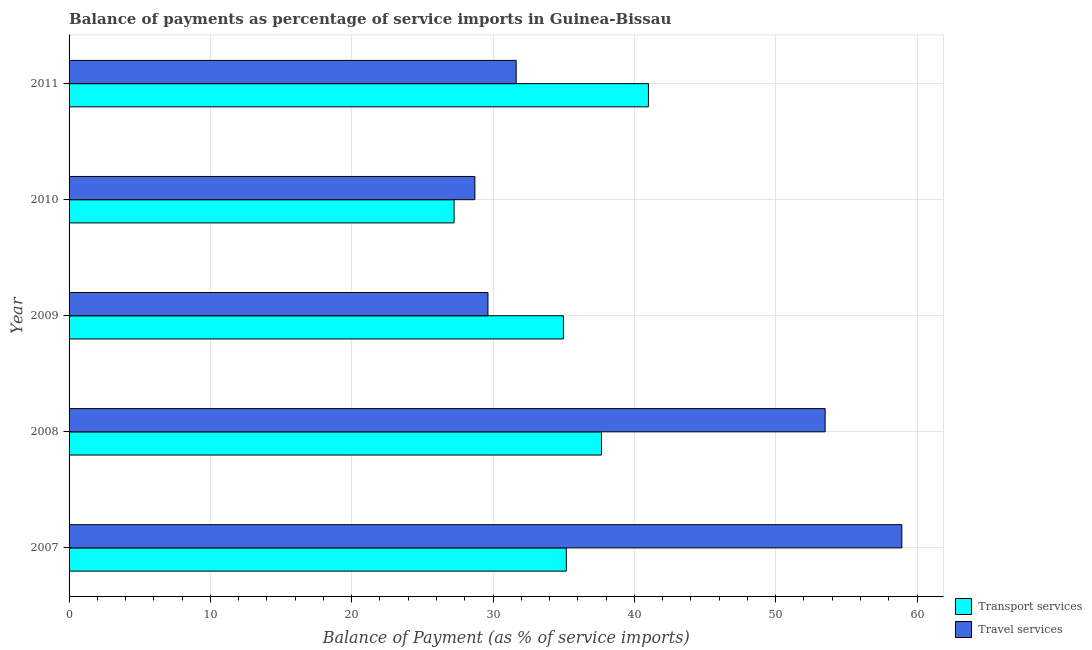How many different coloured bars are there?
Give a very brief answer. 2. Are the number of bars on each tick of the Y-axis equal?
Offer a terse response. Yes. How many bars are there on the 5th tick from the top?
Your answer should be compact. 2. How many bars are there on the 4th tick from the bottom?
Your response must be concise. 2. What is the balance of payments of travel services in 2009?
Your answer should be very brief. 29.64. Across all years, what is the maximum balance of payments of transport services?
Keep it short and to the point. 40.99. Across all years, what is the minimum balance of payments of travel services?
Provide a short and direct response. 28.71. In which year was the balance of payments of travel services minimum?
Provide a short and direct response. 2010. What is the total balance of payments of transport services in the graph?
Your answer should be very brief. 176.07. What is the difference between the balance of payments of transport services in 2008 and that in 2011?
Provide a short and direct response. -3.32. What is the difference between the balance of payments of transport services in 2008 and the balance of payments of travel services in 2007?
Ensure brevity in your answer.  -21.25. What is the average balance of payments of transport services per year?
Your answer should be compact. 35.22. In the year 2011, what is the difference between the balance of payments of travel services and balance of payments of transport services?
Offer a very short reply. -9.36. In how many years, is the balance of payments of transport services greater than 40 %?
Give a very brief answer. 1. What is the ratio of the balance of payments of transport services in 2007 to that in 2011?
Your answer should be compact. 0.86. Is the balance of payments of travel services in 2007 less than that in 2009?
Provide a succinct answer. No. Is the difference between the balance of payments of transport services in 2010 and 2011 greater than the difference between the balance of payments of travel services in 2010 and 2011?
Offer a terse response. No. What is the difference between the highest and the second highest balance of payments of transport services?
Give a very brief answer. 3.32. What is the difference between the highest and the lowest balance of payments of transport services?
Ensure brevity in your answer.  13.75. Is the sum of the balance of payments of transport services in 2007 and 2011 greater than the maximum balance of payments of travel services across all years?
Provide a succinct answer. Yes. What does the 1st bar from the top in 2010 represents?
Your answer should be very brief. Travel services. What does the 2nd bar from the bottom in 2011 represents?
Provide a succinct answer. Travel services. How many bars are there?
Ensure brevity in your answer.  10. Are all the bars in the graph horizontal?
Provide a succinct answer. Yes. How many years are there in the graph?
Provide a succinct answer. 5. What is the difference between two consecutive major ticks on the X-axis?
Offer a very short reply. 10. Does the graph contain any zero values?
Your answer should be compact. No. Does the graph contain grids?
Provide a succinct answer. Yes. Where does the legend appear in the graph?
Your answer should be very brief. Bottom right. How many legend labels are there?
Offer a terse response. 2. What is the title of the graph?
Provide a succinct answer. Balance of payments as percentage of service imports in Guinea-Bissau. What is the label or title of the X-axis?
Provide a succinct answer. Balance of Payment (as % of service imports). What is the Balance of Payment (as % of service imports) of Transport services in 2007?
Offer a terse response. 35.18. What is the Balance of Payment (as % of service imports) in Travel services in 2007?
Your response must be concise. 58.92. What is the Balance of Payment (as % of service imports) of Transport services in 2008?
Your answer should be compact. 37.67. What is the Balance of Payment (as % of service imports) of Travel services in 2008?
Make the answer very short. 53.5. What is the Balance of Payment (as % of service imports) in Transport services in 2009?
Your answer should be compact. 34.98. What is the Balance of Payment (as % of service imports) in Travel services in 2009?
Make the answer very short. 29.64. What is the Balance of Payment (as % of service imports) of Transport services in 2010?
Make the answer very short. 27.24. What is the Balance of Payment (as % of service imports) in Travel services in 2010?
Your response must be concise. 28.71. What is the Balance of Payment (as % of service imports) of Transport services in 2011?
Ensure brevity in your answer.  40.99. What is the Balance of Payment (as % of service imports) in Travel services in 2011?
Ensure brevity in your answer.  31.64. Across all years, what is the maximum Balance of Payment (as % of service imports) in Transport services?
Offer a terse response. 40.99. Across all years, what is the maximum Balance of Payment (as % of service imports) in Travel services?
Give a very brief answer. 58.92. Across all years, what is the minimum Balance of Payment (as % of service imports) in Transport services?
Provide a short and direct response. 27.24. Across all years, what is the minimum Balance of Payment (as % of service imports) of Travel services?
Your answer should be compact. 28.71. What is the total Balance of Payment (as % of service imports) of Transport services in the graph?
Ensure brevity in your answer.  176.07. What is the total Balance of Payment (as % of service imports) of Travel services in the graph?
Offer a very short reply. 202.41. What is the difference between the Balance of Payment (as % of service imports) of Transport services in 2007 and that in 2008?
Make the answer very short. -2.49. What is the difference between the Balance of Payment (as % of service imports) of Travel services in 2007 and that in 2008?
Offer a terse response. 5.43. What is the difference between the Balance of Payment (as % of service imports) of Transport services in 2007 and that in 2009?
Provide a succinct answer. 0.21. What is the difference between the Balance of Payment (as % of service imports) in Travel services in 2007 and that in 2009?
Your answer should be very brief. 29.29. What is the difference between the Balance of Payment (as % of service imports) in Transport services in 2007 and that in 2010?
Give a very brief answer. 7.94. What is the difference between the Balance of Payment (as % of service imports) of Travel services in 2007 and that in 2010?
Keep it short and to the point. 30.21. What is the difference between the Balance of Payment (as % of service imports) of Transport services in 2007 and that in 2011?
Make the answer very short. -5.81. What is the difference between the Balance of Payment (as % of service imports) of Travel services in 2007 and that in 2011?
Your answer should be compact. 27.29. What is the difference between the Balance of Payment (as % of service imports) of Transport services in 2008 and that in 2009?
Offer a very short reply. 2.69. What is the difference between the Balance of Payment (as % of service imports) in Travel services in 2008 and that in 2009?
Offer a terse response. 23.86. What is the difference between the Balance of Payment (as % of service imports) in Transport services in 2008 and that in 2010?
Give a very brief answer. 10.43. What is the difference between the Balance of Payment (as % of service imports) of Travel services in 2008 and that in 2010?
Your answer should be very brief. 24.78. What is the difference between the Balance of Payment (as % of service imports) in Transport services in 2008 and that in 2011?
Your response must be concise. -3.32. What is the difference between the Balance of Payment (as % of service imports) in Travel services in 2008 and that in 2011?
Provide a short and direct response. 21.86. What is the difference between the Balance of Payment (as % of service imports) of Transport services in 2009 and that in 2010?
Your answer should be very brief. 7.74. What is the difference between the Balance of Payment (as % of service imports) in Travel services in 2009 and that in 2010?
Provide a short and direct response. 0.92. What is the difference between the Balance of Payment (as % of service imports) of Transport services in 2009 and that in 2011?
Offer a very short reply. -6.02. What is the difference between the Balance of Payment (as % of service imports) in Travel services in 2009 and that in 2011?
Your answer should be very brief. -2. What is the difference between the Balance of Payment (as % of service imports) in Transport services in 2010 and that in 2011?
Your answer should be very brief. -13.75. What is the difference between the Balance of Payment (as % of service imports) in Travel services in 2010 and that in 2011?
Ensure brevity in your answer.  -2.92. What is the difference between the Balance of Payment (as % of service imports) of Transport services in 2007 and the Balance of Payment (as % of service imports) of Travel services in 2008?
Your answer should be very brief. -18.31. What is the difference between the Balance of Payment (as % of service imports) of Transport services in 2007 and the Balance of Payment (as % of service imports) of Travel services in 2009?
Your answer should be compact. 5.55. What is the difference between the Balance of Payment (as % of service imports) in Transport services in 2007 and the Balance of Payment (as % of service imports) in Travel services in 2010?
Offer a terse response. 6.47. What is the difference between the Balance of Payment (as % of service imports) of Transport services in 2007 and the Balance of Payment (as % of service imports) of Travel services in 2011?
Make the answer very short. 3.55. What is the difference between the Balance of Payment (as % of service imports) of Transport services in 2008 and the Balance of Payment (as % of service imports) of Travel services in 2009?
Make the answer very short. 8.03. What is the difference between the Balance of Payment (as % of service imports) in Transport services in 2008 and the Balance of Payment (as % of service imports) in Travel services in 2010?
Provide a succinct answer. 8.96. What is the difference between the Balance of Payment (as % of service imports) in Transport services in 2008 and the Balance of Payment (as % of service imports) in Travel services in 2011?
Make the answer very short. 6.04. What is the difference between the Balance of Payment (as % of service imports) in Transport services in 2009 and the Balance of Payment (as % of service imports) in Travel services in 2010?
Your answer should be very brief. 6.26. What is the difference between the Balance of Payment (as % of service imports) in Transport services in 2009 and the Balance of Payment (as % of service imports) in Travel services in 2011?
Your response must be concise. 3.34. What is the difference between the Balance of Payment (as % of service imports) of Transport services in 2010 and the Balance of Payment (as % of service imports) of Travel services in 2011?
Your answer should be very brief. -4.39. What is the average Balance of Payment (as % of service imports) in Transport services per year?
Your answer should be very brief. 35.21. What is the average Balance of Payment (as % of service imports) in Travel services per year?
Provide a succinct answer. 40.48. In the year 2007, what is the difference between the Balance of Payment (as % of service imports) in Transport services and Balance of Payment (as % of service imports) in Travel services?
Offer a very short reply. -23.74. In the year 2008, what is the difference between the Balance of Payment (as % of service imports) in Transport services and Balance of Payment (as % of service imports) in Travel services?
Give a very brief answer. -15.83. In the year 2009, what is the difference between the Balance of Payment (as % of service imports) in Transport services and Balance of Payment (as % of service imports) in Travel services?
Provide a succinct answer. 5.34. In the year 2010, what is the difference between the Balance of Payment (as % of service imports) of Transport services and Balance of Payment (as % of service imports) of Travel services?
Make the answer very short. -1.47. In the year 2011, what is the difference between the Balance of Payment (as % of service imports) in Transport services and Balance of Payment (as % of service imports) in Travel services?
Provide a short and direct response. 9.36. What is the ratio of the Balance of Payment (as % of service imports) of Transport services in 2007 to that in 2008?
Ensure brevity in your answer.  0.93. What is the ratio of the Balance of Payment (as % of service imports) in Travel services in 2007 to that in 2008?
Your response must be concise. 1.1. What is the ratio of the Balance of Payment (as % of service imports) of Transport services in 2007 to that in 2009?
Your response must be concise. 1.01. What is the ratio of the Balance of Payment (as % of service imports) of Travel services in 2007 to that in 2009?
Your answer should be very brief. 1.99. What is the ratio of the Balance of Payment (as % of service imports) of Transport services in 2007 to that in 2010?
Your answer should be very brief. 1.29. What is the ratio of the Balance of Payment (as % of service imports) of Travel services in 2007 to that in 2010?
Keep it short and to the point. 2.05. What is the ratio of the Balance of Payment (as % of service imports) of Transport services in 2007 to that in 2011?
Ensure brevity in your answer.  0.86. What is the ratio of the Balance of Payment (as % of service imports) in Travel services in 2007 to that in 2011?
Your answer should be very brief. 1.86. What is the ratio of the Balance of Payment (as % of service imports) in Transport services in 2008 to that in 2009?
Give a very brief answer. 1.08. What is the ratio of the Balance of Payment (as % of service imports) in Travel services in 2008 to that in 2009?
Offer a terse response. 1.8. What is the ratio of the Balance of Payment (as % of service imports) in Transport services in 2008 to that in 2010?
Make the answer very short. 1.38. What is the ratio of the Balance of Payment (as % of service imports) in Travel services in 2008 to that in 2010?
Offer a very short reply. 1.86. What is the ratio of the Balance of Payment (as % of service imports) of Transport services in 2008 to that in 2011?
Offer a terse response. 0.92. What is the ratio of the Balance of Payment (as % of service imports) of Travel services in 2008 to that in 2011?
Your response must be concise. 1.69. What is the ratio of the Balance of Payment (as % of service imports) of Transport services in 2009 to that in 2010?
Your response must be concise. 1.28. What is the ratio of the Balance of Payment (as % of service imports) of Travel services in 2009 to that in 2010?
Make the answer very short. 1.03. What is the ratio of the Balance of Payment (as % of service imports) in Transport services in 2009 to that in 2011?
Give a very brief answer. 0.85. What is the ratio of the Balance of Payment (as % of service imports) in Travel services in 2009 to that in 2011?
Keep it short and to the point. 0.94. What is the ratio of the Balance of Payment (as % of service imports) in Transport services in 2010 to that in 2011?
Provide a short and direct response. 0.66. What is the ratio of the Balance of Payment (as % of service imports) in Travel services in 2010 to that in 2011?
Provide a succinct answer. 0.91. What is the difference between the highest and the second highest Balance of Payment (as % of service imports) of Transport services?
Your response must be concise. 3.32. What is the difference between the highest and the second highest Balance of Payment (as % of service imports) of Travel services?
Your answer should be compact. 5.43. What is the difference between the highest and the lowest Balance of Payment (as % of service imports) in Transport services?
Provide a short and direct response. 13.75. What is the difference between the highest and the lowest Balance of Payment (as % of service imports) of Travel services?
Provide a short and direct response. 30.21. 